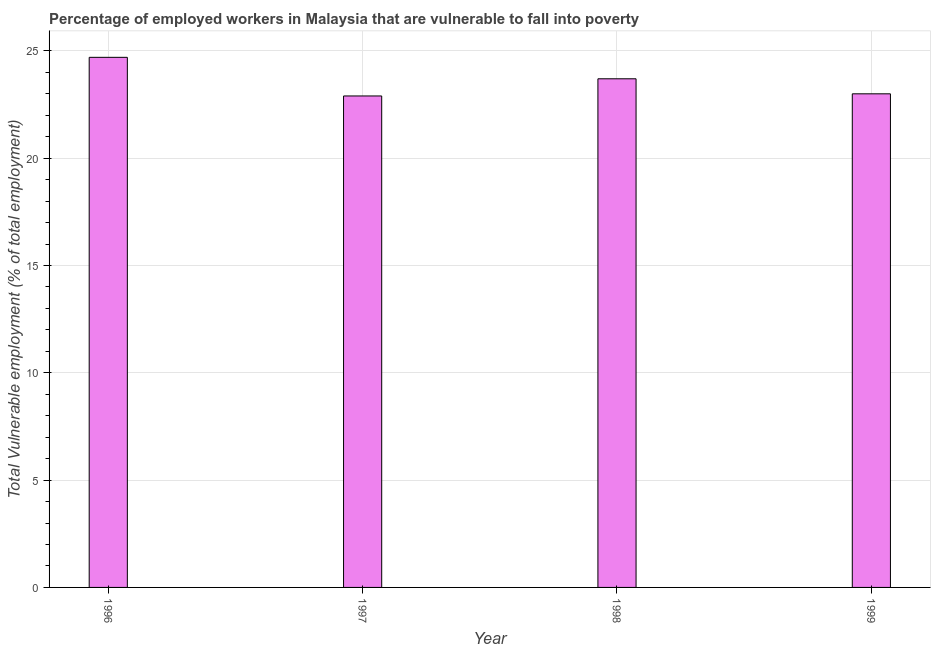Does the graph contain any zero values?
Provide a succinct answer. No. What is the title of the graph?
Keep it short and to the point. Percentage of employed workers in Malaysia that are vulnerable to fall into poverty. What is the label or title of the Y-axis?
Give a very brief answer. Total Vulnerable employment (% of total employment). What is the total vulnerable employment in 1998?
Give a very brief answer. 23.7. Across all years, what is the maximum total vulnerable employment?
Make the answer very short. 24.7. Across all years, what is the minimum total vulnerable employment?
Your answer should be very brief. 22.9. What is the sum of the total vulnerable employment?
Make the answer very short. 94.3. What is the average total vulnerable employment per year?
Give a very brief answer. 23.57. What is the median total vulnerable employment?
Offer a terse response. 23.35. In how many years, is the total vulnerable employment greater than 23 %?
Make the answer very short. 2. What is the ratio of the total vulnerable employment in 1997 to that in 1998?
Ensure brevity in your answer.  0.97. Is the difference between the total vulnerable employment in 1998 and 1999 greater than the difference between any two years?
Provide a succinct answer. No. How many bars are there?
Keep it short and to the point. 4. What is the difference between two consecutive major ticks on the Y-axis?
Provide a short and direct response. 5. What is the Total Vulnerable employment (% of total employment) of 1996?
Your answer should be compact. 24.7. What is the Total Vulnerable employment (% of total employment) of 1997?
Make the answer very short. 22.9. What is the Total Vulnerable employment (% of total employment) in 1998?
Keep it short and to the point. 23.7. What is the Total Vulnerable employment (% of total employment) of 1999?
Your answer should be very brief. 23. What is the difference between the Total Vulnerable employment (% of total employment) in 1996 and 1998?
Your answer should be compact. 1. What is the difference between the Total Vulnerable employment (% of total employment) in 1996 and 1999?
Provide a succinct answer. 1.7. What is the ratio of the Total Vulnerable employment (% of total employment) in 1996 to that in 1997?
Keep it short and to the point. 1.08. What is the ratio of the Total Vulnerable employment (% of total employment) in 1996 to that in 1998?
Provide a short and direct response. 1.04. What is the ratio of the Total Vulnerable employment (% of total employment) in 1996 to that in 1999?
Offer a terse response. 1.07. What is the ratio of the Total Vulnerable employment (% of total employment) in 1997 to that in 1998?
Provide a succinct answer. 0.97. What is the ratio of the Total Vulnerable employment (% of total employment) in 1997 to that in 1999?
Ensure brevity in your answer.  1. 